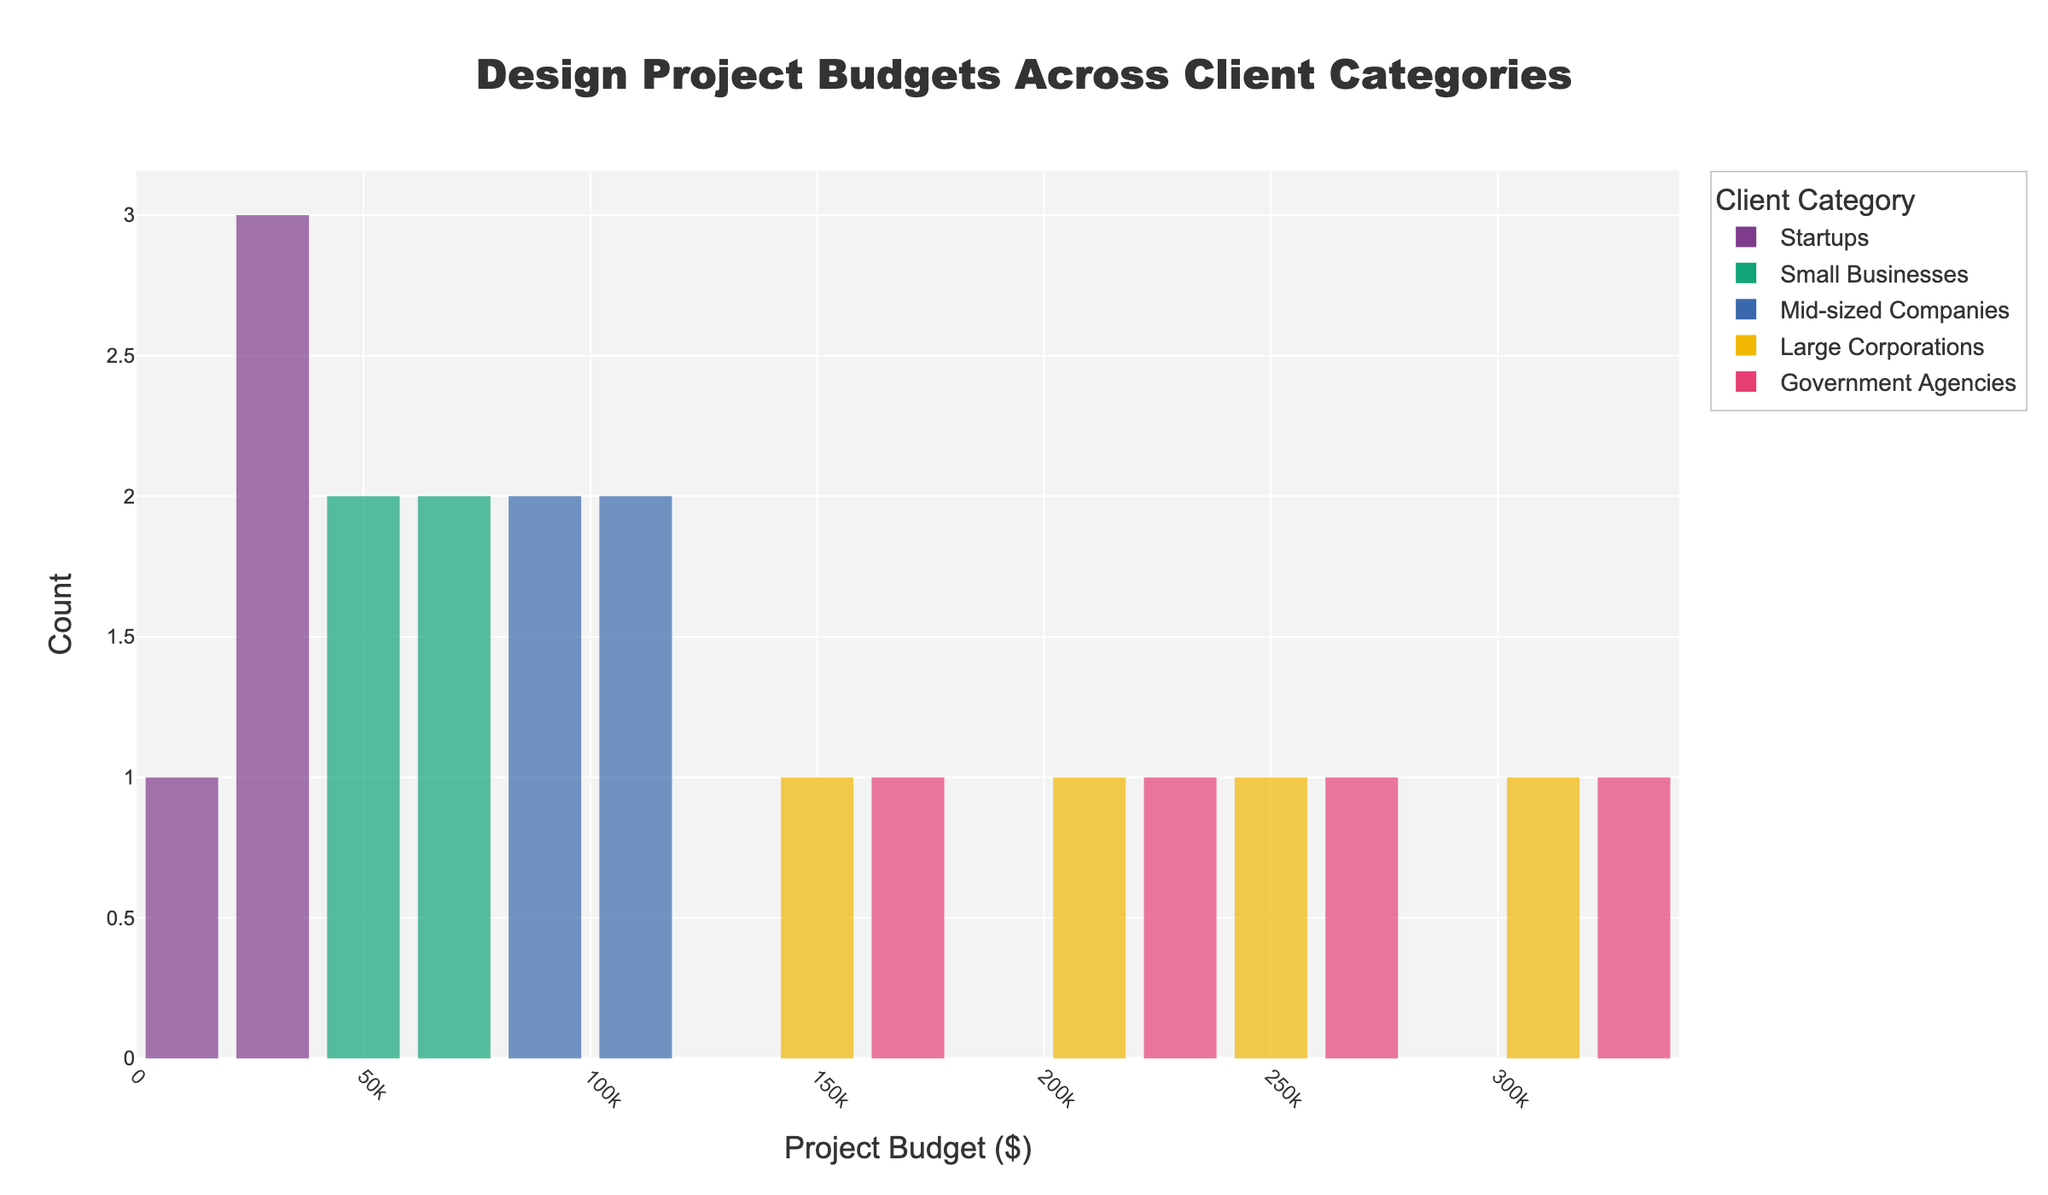What is the title of the histogram? The title is clearly visible at the top of the histogram.
Answer: Design Project Budgets Across Client Categories How many client categories are represented in the histogram? There are multiple color-coded bars in the histogram, each representing a different client category. Count the distinct colors.
Answer: 5 Which client category has the highest project budgets? Look for the client category with bars positioned farthest to the right on the x-axis, indicating higher budget values.
Answer: Large Corporations What's the range of project budgets for Startups? Identify the leftmost and rightmost edges of the Startups category bars on the x-axis. Subtract the minimum value from the maximum value.
Answer: $15,000 to $35,000 How many project budgets fall within the $50,000 to $100,000 range for Small Businesses? Count the bars for Small Businesses that fall within the $50,000 to $100,000 range on the x-axis.
Answer: 2 Which client category has the most evenly distributed project budgets? Identify the client category whose bars are evenly spread across the x-axis, indicating a more even distribution.
Answer: Mid-sized Companies Which client category has the fewest project budgets? Look for the category with the least number of bars on the histogram.
Answer: Startups What is the average project budget for Government Agencies? Identify the bars for Government Agencies and their corresponding budget values. Add them up and divide by the number of bars.
Answer: $250,000 Which two client categories have overlapping budget ranges, and what is that range? Identify client categories with bars that overlap on the x-axis. Note the overlapping budget range on the x-axis where their bars coincide.
Answer: Large Corporations and Government Agencies overlap in the $200,000 to $300,000 range Compared to Mid-sized Companies, do Small Businesses tend to have higher, lower, or similar project budget values? Observe the position of the bars for Mid-sized Companies and Small Businesses on the x-axis. Compare their positions to determine if they are generally higher, lower, or similar.
Answer: Lower 